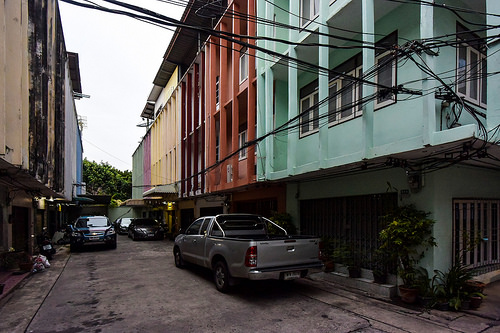<image>
Is the truck under the house? Yes. The truck is positioned underneath the house, with the house above it in the vertical space. Is there a car behind the car? No. The car is not behind the car. From this viewpoint, the car appears to be positioned elsewhere in the scene. Where is the truck in relation to the building? Is it to the right of the building? No. The truck is not to the right of the building. The horizontal positioning shows a different relationship. 